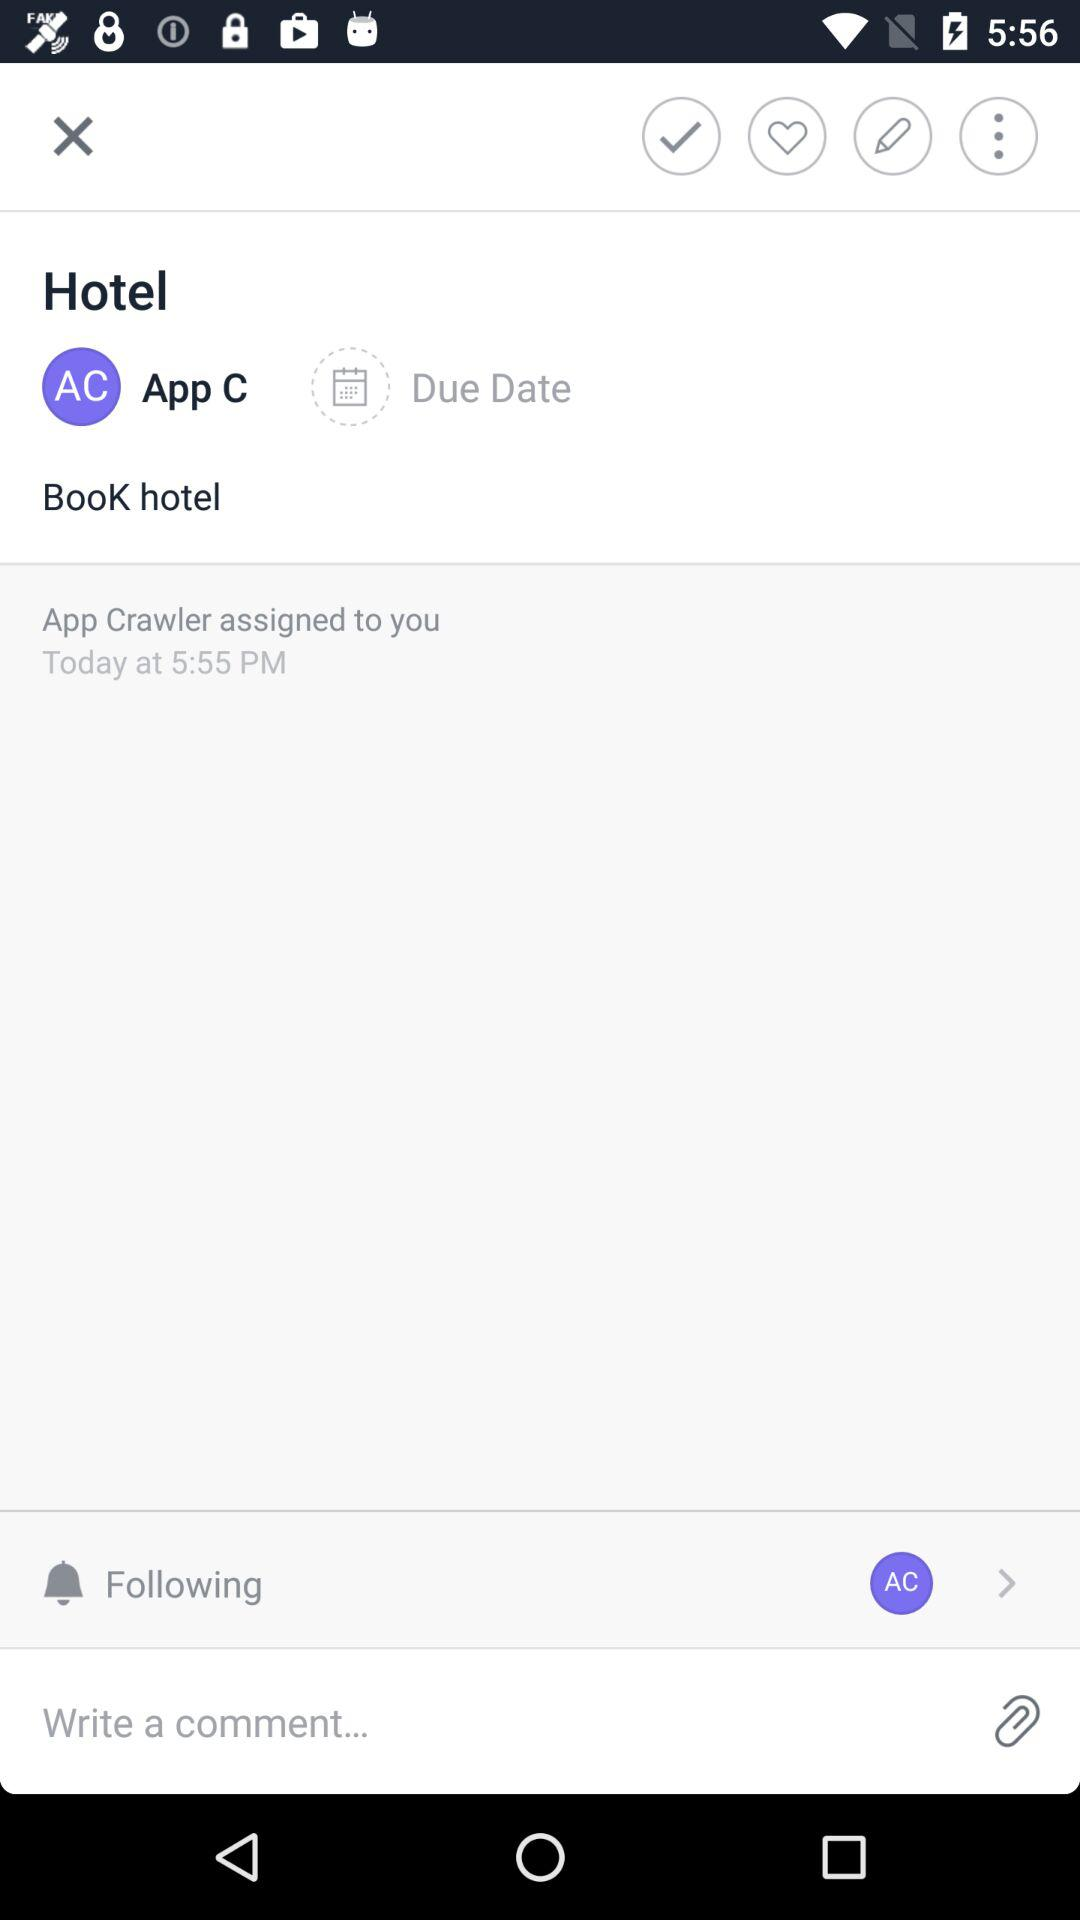What is the time? The time is 5:55 pm. 